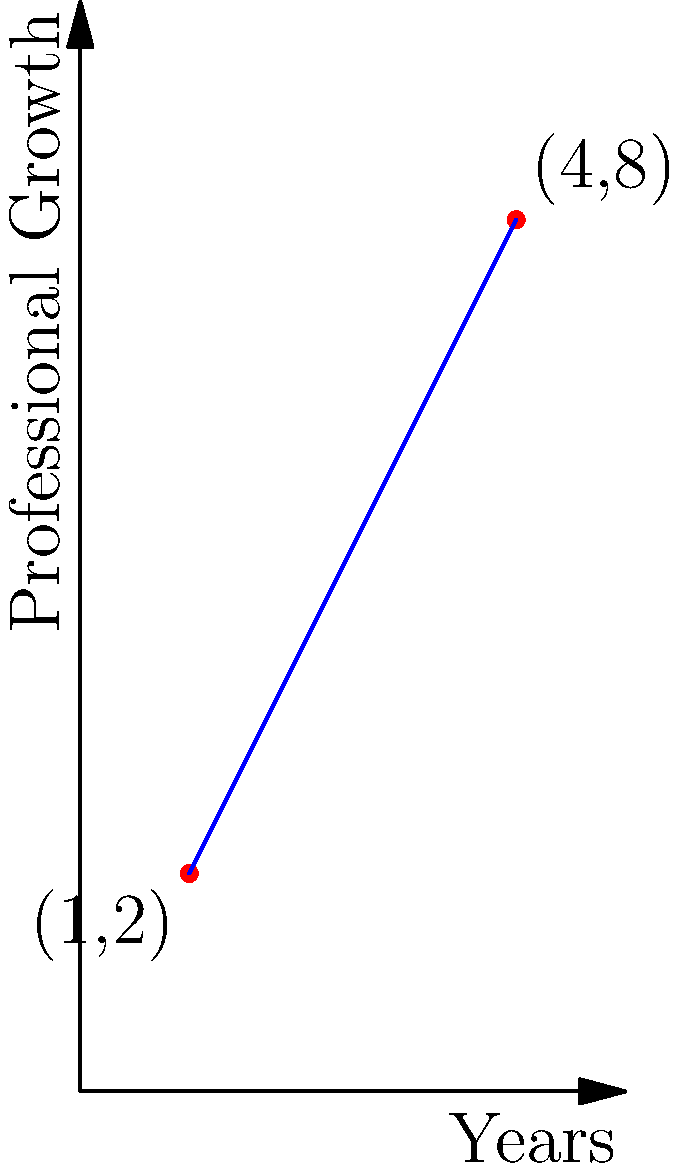Given the graph representing Matanat's professional growth over time, determine the slope of the line connecting the points (1,2) and (4,8). What does this slope represent in terms of Matanat's professional development? To find the slope of the line connecting two points, we use the slope formula:

$$ m = \frac{y_2 - y_1}{x_2 - x_1} $$

Where $(x_1, y_1)$ is the first point and $(x_2, y_2)$ is the second point.

Step 1: Identify the coordinates of the two points:
Point 1: $(1, 2)$
Point 2: $(4, 8)$

Step 2: Plug these values into the slope formula:

$$ m = \frac{8 - 2}{4 - 1} = \frac{6}{3} = 2 $$

Step 3: Interpret the result:
The slope of 2 means that for every 1 unit increase in x (representing 1 year), y increases by 2 units (representing professional growth).

Therefore, the slope represents Matanat's rate of professional growth per year. A slope of 2 indicates that Matanat's professional growth increases by 2 units each year, showing a steady and significant improvement in her professional development over time.
Answer: Slope = 2, representing 2 units of professional growth per year 